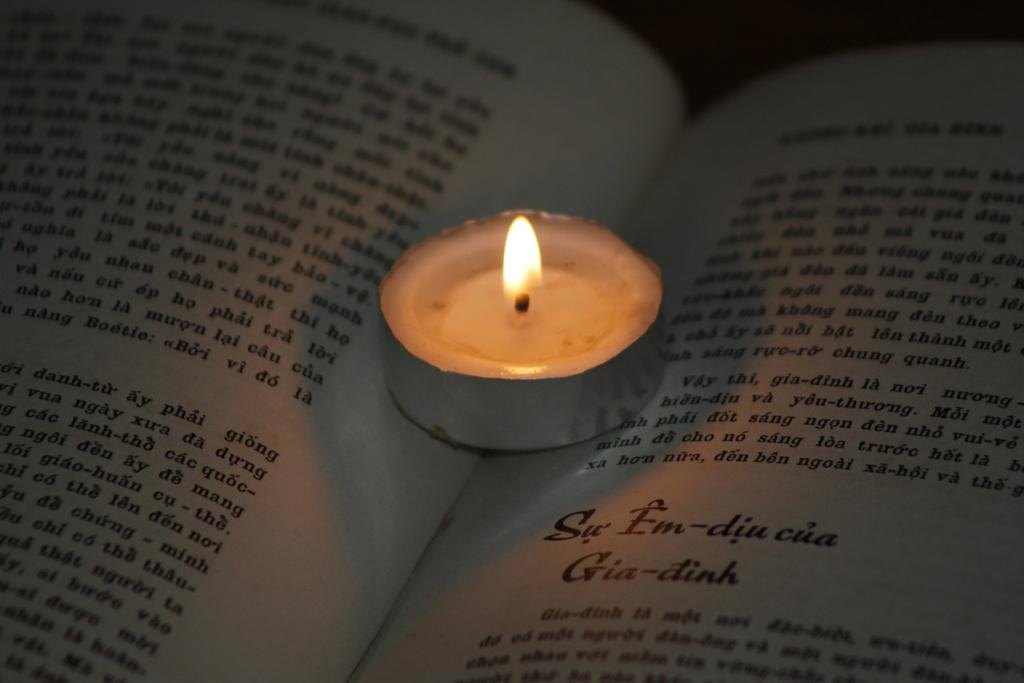What is placed on top of the book in the image? There is a candle on a book in the image. What can be observed about the lighting in the image? The background of the image is dark. What type of music can be heard coming from the bears in the image? There are no bears present in the image, so it's not possible to determine what, if any, music might be heard. 